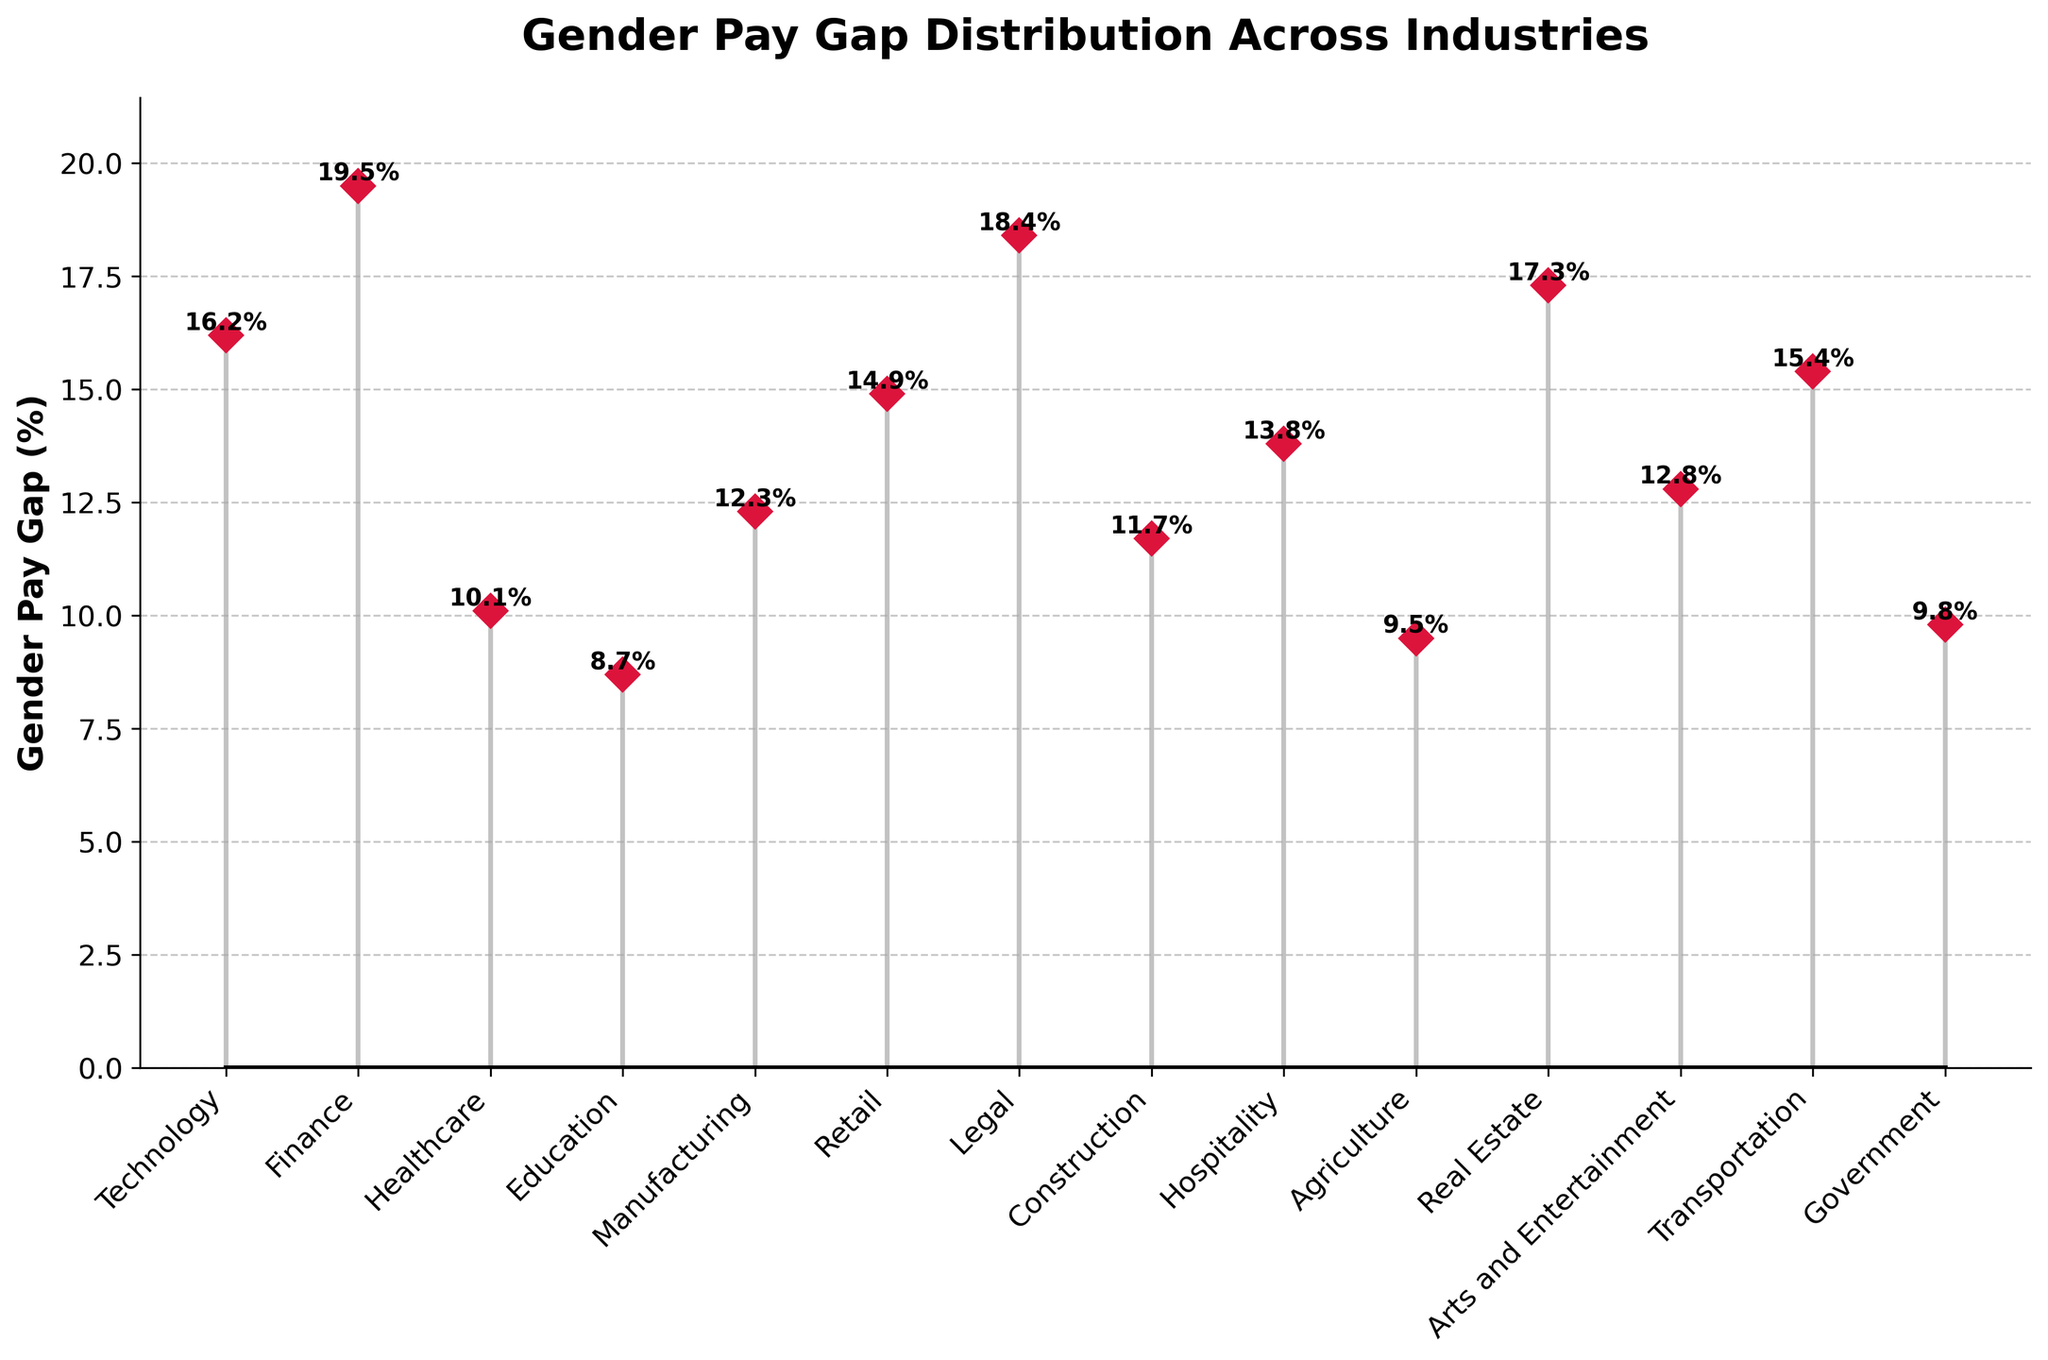What is the title of the plot? The title is located at the top of the plot and is bolded to stand out. It reads 'Gender Pay Gap Distribution Across Industries'.
Answer: Gender Pay Gap Distribution Across Industries Which industry has the smallest gender pay gap? Look at the markers on the plot, identify the one with the lowest percentage. Here, 'Education' has the smallest gap at 8.7%.
Answer: Education How much greater is the gender pay gap in Finance compared to Agriculture? Find the percentages for Finance (19.5%) and Agriculture (9.5%). Subtract the Agriculture pay gap from the Finance pay gap. 19.5 - 9.5 = 10%.
Answer: 10% Which industries have a gender pay gap greater than 15%? Scan through the plot to identify all markers above the 15% line. The industries are Technology, Finance, Legal, Real Estate, and Transportation.
Answer: Technology, Finance, Legal, Real Estate, Transportation What is the average gender pay gap across all industries? Add all the percentages together: (16.2 + 19.5 + 10.1 + 8.7 + 12.3 + 14.9 + 18.4 + 11.7 + 13.8 + 9.5 + 17.3 + 12.8 + 15.4 + 9.8). Then divide the sum by the number of industries (14). Average = 190.4 / 14 = 13.6%.
Answer: 13.6% Which industry has the largest gender pay gap? Identify the industry with the highest marker. Here, 'Finance' has the largest gender pay gap at 19.5%.
Answer: Finance How does the gender pay gap in Healthcare compare to that in Hospitality? Find the percentages for Healthcare (10.1%) and Hospitality (13.8%). Healthcare's gap is less.
Answer: Healthcare's gap is less What is the median gender pay gap value across these industries? Arrange the values in ascending order and find the middle value(s). If there's an even number of values, calculate the average of the two middle values. Ordered values: 8.7, 9.5, 9.8, 10.1, 11.7, 12.3, 12.8, 13.8, 14.9, 15.4, 16.2, 17.3, 18.4, 19.5. Median is the average of 12.8 and 13.8, so (12.8 + 13.8) / 2 = 13.3%.
Answer: 13.3% How many industries have a gender pay gap of less than 10%? Count the number of industries where the marker is below the 10% line. Those are Education, Agriculture, and Government. There are 3 such industries.
Answer: 3 